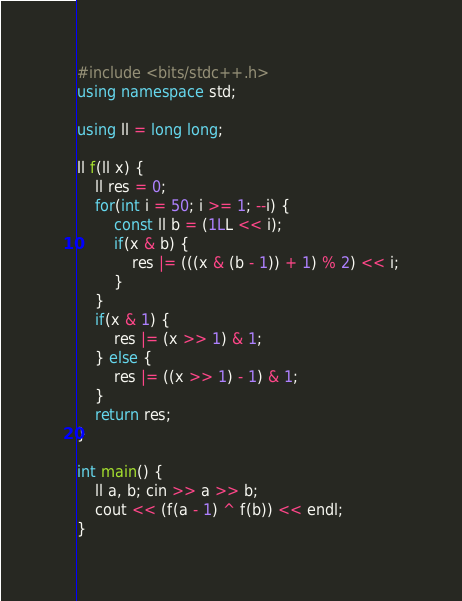Convert code to text. <code><loc_0><loc_0><loc_500><loc_500><_C++_>#include <bits/stdc++.h>
using namespace std;

using ll = long long;

ll f(ll x) {
    ll res = 0;
    for(int i = 50; i >= 1; --i) {
        const ll b = (1LL << i);
        if(x & b) {
            res |= (((x & (b - 1)) + 1) % 2) << i;
        }
    }
    if(x & 1) {
        res |= (x >> 1) & 1;
    } else {
        res |= ((x >> 1) - 1) & 1;
    }
    return res;
}

int main() {
    ll a, b; cin >> a >> b;
    cout << (f(a - 1) ^ f(b)) << endl;
}
</code> 